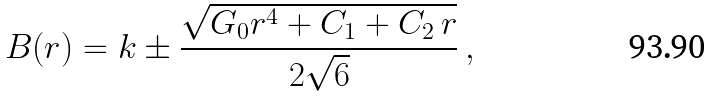Convert formula to latex. <formula><loc_0><loc_0><loc_500><loc_500>B ( r ) = k \pm \frac { \sqrt { G _ { 0 } r ^ { 4 } + C _ { 1 } + C _ { 2 } \, r } } { 2 \sqrt { 6 } } \, ,</formula> 